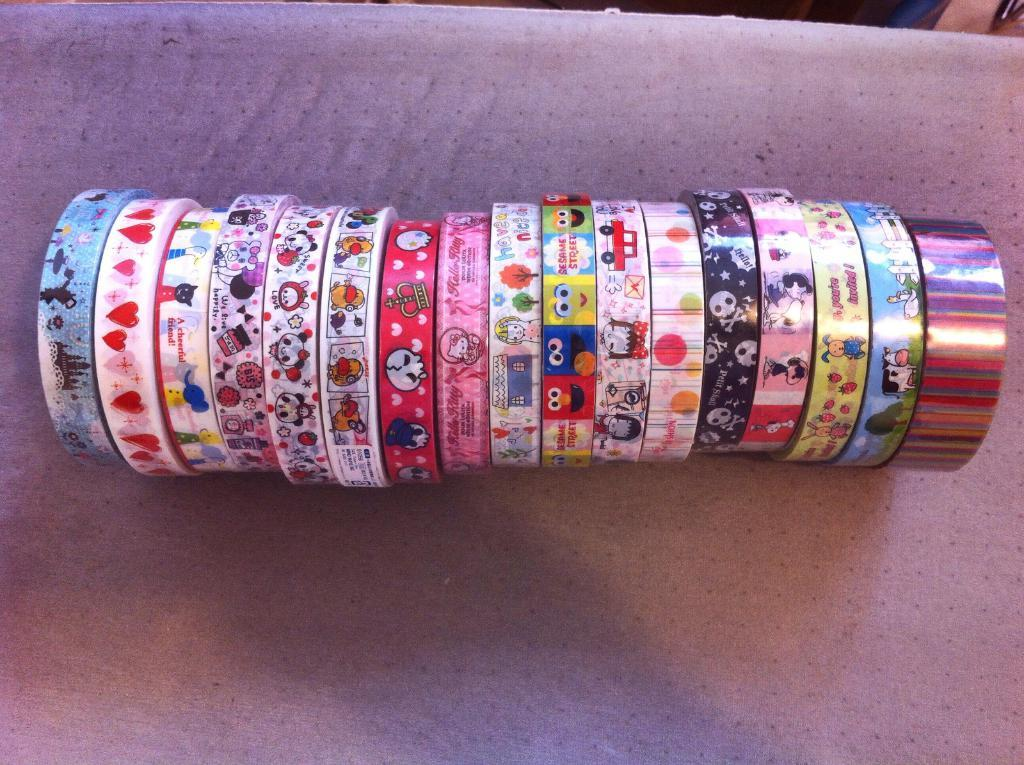What types of tapes are visible in the image? There are different colors and designs of tapes in the image. How are the tapes arranged in the image? The tapes are arranged in a line. On what surface are the tapes placed in the image? The tapes are placed on a plane surface. What type of picture is hanging on the wall in the image? There is no picture hanging on the wall in the image; it only features different colors and designs of tapes arranged in a line on a plane surface. 